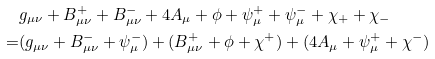<formula> <loc_0><loc_0><loc_500><loc_500>& g _ { \mu \nu } + B _ { \mu \nu } ^ { + } + B _ { \mu \nu } ^ { - } + 4 A _ { \mu } + \phi + \psi _ { \mu } ^ { + } + \psi _ { \mu } ^ { - } + \chi _ { + } + \chi _ { - } \\ = & ( g _ { \mu \nu } + B _ { \mu \nu } ^ { - } + \psi _ { \mu } ^ { - } ) + ( B _ { \mu \nu } ^ { + } + \phi + \chi ^ { + } ) + ( 4 A _ { \mu } + \psi _ { \mu } ^ { + } + \chi ^ { - } )</formula> 